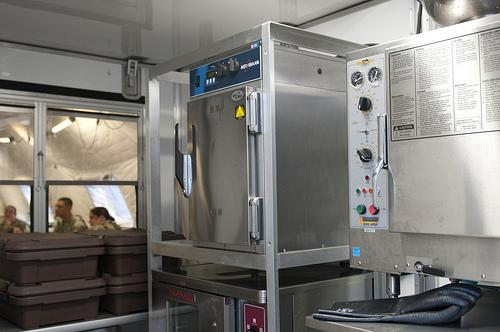Question: when is this taking place?
Choices:
A. Nighttime.
B. Daytime.
C. Afternoon.
D. Evening.
Answer with the letter. Answer: B Question: what kind of room is this?
Choices:
A. Bedroom.
B. Bathroom.
C. Kitchen.
D. Living room.
Answer with the letter. Answer: C Question: how many pairs of gloves are in the photo?
Choices:
A. One.
B. Two.
C. Three.
D. Four.
Answer with the letter. Answer: A Question: what color are the appliances in the room?
Choices:
A. Black.
B. White.
C. Silver.
D. Grey.
Answer with the letter. Answer: C Question: how many trays are in front of the window in the photo?
Choices:
A. Seven.
B. Eight.
C. Six.
D. Five.
Answer with the letter. Answer: B Question: where is this taking place?
Choices:
A. Living room.
B. Swimming pool.
C. Park.
D. A kitchen.
Answer with the letter. Answer: D 